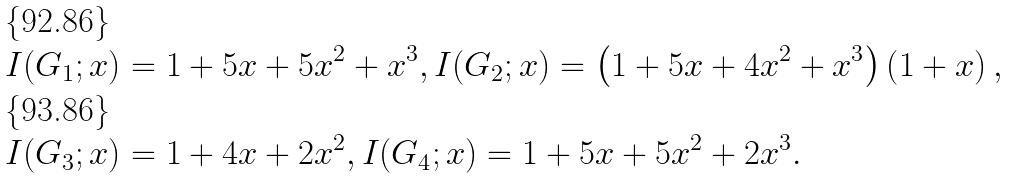Convert formula to latex. <formula><loc_0><loc_0><loc_500><loc_500>I ( G _ { 1 } ; x ) & = 1 + 5 x + 5 x ^ { 2 } + x ^ { 3 } , I ( G _ { 2 } ; x ) = \left ( 1 + 5 x + 4 x ^ { 2 } + x ^ { 3 } \right ) \left ( 1 + x \right ) , \\ I ( G _ { 3 } ; x ) & = 1 + 4 x + 2 x ^ { 2 } , I ( G _ { 4 } ; x ) = 1 + 5 x + 5 x ^ { 2 } + 2 x ^ { 3 } .</formula> 